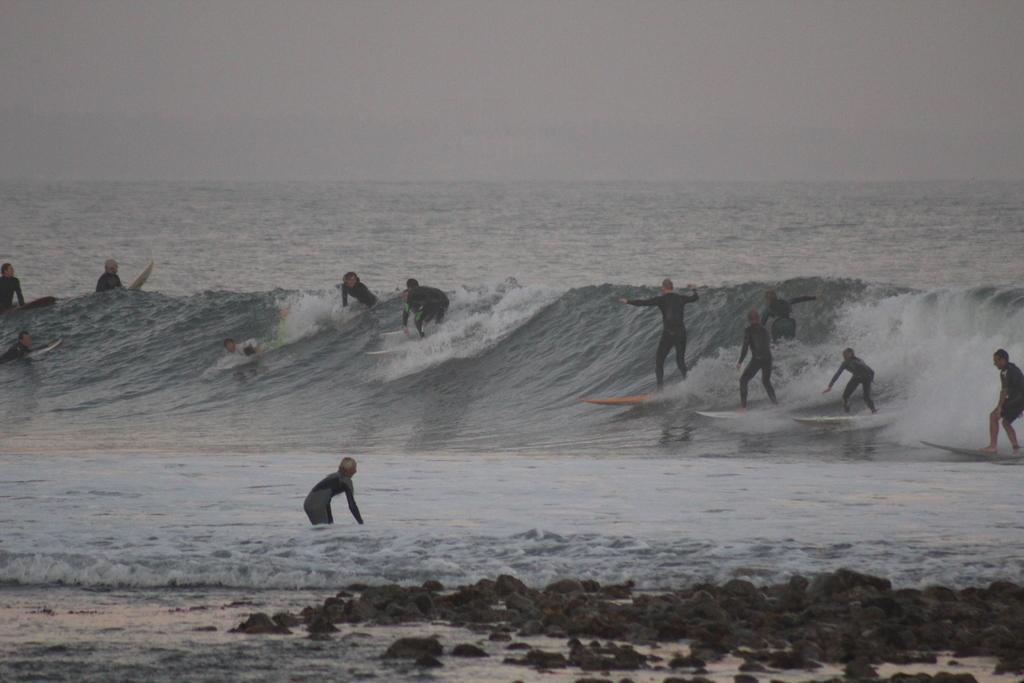Can you describe this image briefly? In this picture, we see people surfing on the water. This water might be in the sea. At the top of the picture, we see the sky. At the bottom of the picture, we see the stones. 